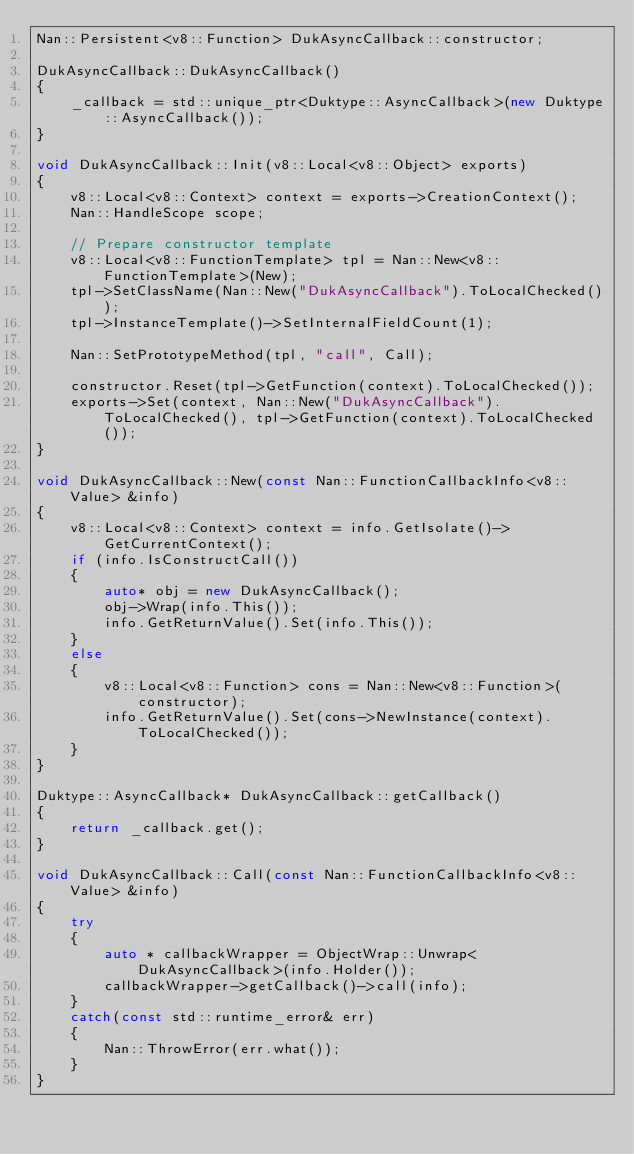Convert code to text. <code><loc_0><loc_0><loc_500><loc_500><_C++_>Nan::Persistent<v8::Function> DukAsyncCallback::constructor;

DukAsyncCallback::DukAsyncCallback()
{
    _callback = std::unique_ptr<Duktype::AsyncCallback>(new Duktype::AsyncCallback());
}

void DukAsyncCallback::Init(v8::Local<v8::Object> exports)
{
    v8::Local<v8::Context> context = exports->CreationContext();
    Nan::HandleScope scope;

    // Prepare constructor template
    v8::Local<v8::FunctionTemplate> tpl = Nan::New<v8::FunctionTemplate>(New);
    tpl->SetClassName(Nan::New("DukAsyncCallback").ToLocalChecked());
    tpl->InstanceTemplate()->SetInternalFieldCount(1);

    Nan::SetPrototypeMethod(tpl, "call", Call);

    constructor.Reset(tpl->GetFunction(context).ToLocalChecked());
    exports->Set(context, Nan::New("DukAsyncCallback").ToLocalChecked(), tpl->GetFunction(context).ToLocalChecked());
}

void DukAsyncCallback::New(const Nan::FunctionCallbackInfo<v8::Value> &info)
{
    v8::Local<v8::Context> context = info.GetIsolate()->GetCurrentContext();
    if (info.IsConstructCall())
    {
        auto* obj = new DukAsyncCallback();
        obj->Wrap(info.This());
        info.GetReturnValue().Set(info.This());
    }
    else
    {
        v8::Local<v8::Function> cons = Nan::New<v8::Function>(constructor);
        info.GetReturnValue().Set(cons->NewInstance(context).ToLocalChecked());
    }
}

Duktype::AsyncCallback* DukAsyncCallback::getCallback()
{
    return _callback.get();
}

void DukAsyncCallback::Call(const Nan::FunctionCallbackInfo<v8::Value> &info)
{
    try
    {
        auto * callbackWrapper = ObjectWrap::Unwrap<DukAsyncCallback>(info.Holder());
        callbackWrapper->getCallback()->call(info);
    }
    catch(const std::runtime_error& err)
    {
        Nan::ThrowError(err.what());
    }
}

</code> 